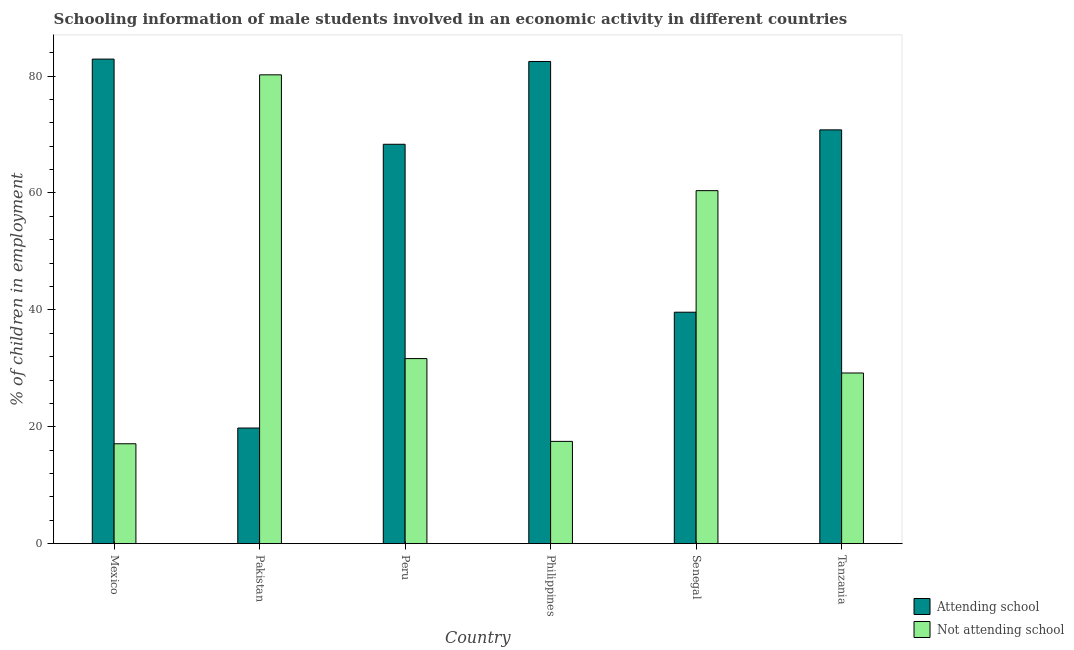How many different coloured bars are there?
Keep it short and to the point. 2. Are the number of bars per tick equal to the number of legend labels?
Make the answer very short. Yes. How many bars are there on the 5th tick from the right?
Your response must be concise. 2. In how many cases, is the number of bars for a given country not equal to the number of legend labels?
Provide a succinct answer. 0. What is the percentage of employed males who are not attending school in Senegal?
Provide a short and direct response. 60.4. Across all countries, what is the maximum percentage of employed males who are attending school?
Offer a terse response. 82.91. Across all countries, what is the minimum percentage of employed males who are attending school?
Your answer should be very brief. 19.79. What is the total percentage of employed males who are not attending school in the graph?
Provide a short and direct response. 236.07. What is the difference between the percentage of employed males who are attending school in Mexico and that in Tanzania?
Provide a succinct answer. 12.11. What is the difference between the percentage of employed males who are not attending school in Mexico and the percentage of employed males who are attending school in Pakistan?
Offer a terse response. -2.69. What is the average percentage of employed males who are attending school per country?
Make the answer very short. 60.65. What is the difference between the percentage of employed males who are not attending school and percentage of employed males who are attending school in Tanzania?
Offer a terse response. -41.6. In how many countries, is the percentage of employed males who are attending school greater than 52 %?
Provide a succinct answer. 4. What is the ratio of the percentage of employed males who are not attending school in Peru to that in Tanzania?
Give a very brief answer. 1.08. What is the difference between the highest and the second highest percentage of employed males who are attending school?
Your answer should be compact. 0.41. What is the difference between the highest and the lowest percentage of employed males who are not attending school?
Give a very brief answer. 63.12. In how many countries, is the percentage of employed males who are not attending school greater than the average percentage of employed males who are not attending school taken over all countries?
Offer a terse response. 2. What does the 2nd bar from the left in Pakistan represents?
Offer a very short reply. Not attending school. What does the 1st bar from the right in Philippines represents?
Provide a succinct answer. Not attending school. How many bars are there?
Ensure brevity in your answer.  12. Are the values on the major ticks of Y-axis written in scientific E-notation?
Provide a short and direct response. No. Does the graph contain any zero values?
Your response must be concise. No. What is the title of the graph?
Keep it short and to the point. Schooling information of male students involved in an economic activity in different countries. Does "Technicians" appear as one of the legend labels in the graph?
Your answer should be compact. No. What is the label or title of the X-axis?
Keep it short and to the point. Country. What is the label or title of the Y-axis?
Your answer should be compact. % of children in employment. What is the % of children in employment in Attending school in Mexico?
Your answer should be compact. 82.91. What is the % of children in employment of Not attending school in Mexico?
Your answer should be very brief. 17.09. What is the % of children in employment of Attending school in Pakistan?
Offer a very short reply. 19.79. What is the % of children in employment in Not attending school in Pakistan?
Provide a short and direct response. 80.21. What is the % of children in employment in Attending school in Peru?
Offer a very short reply. 68.33. What is the % of children in employment in Not attending school in Peru?
Offer a very short reply. 31.67. What is the % of children in employment in Attending school in Philippines?
Give a very brief answer. 82.5. What is the % of children in employment of Not attending school in Philippines?
Provide a short and direct response. 17.5. What is the % of children in employment of Attending school in Senegal?
Offer a terse response. 39.6. What is the % of children in employment of Not attending school in Senegal?
Provide a short and direct response. 60.4. What is the % of children in employment of Attending school in Tanzania?
Ensure brevity in your answer.  70.8. What is the % of children in employment in Not attending school in Tanzania?
Provide a succinct answer. 29.2. Across all countries, what is the maximum % of children in employment of Attending school?
Ensure brevity in your answer.  82.91. Across all countries, what is the maximum % of children in employment in Not attending school?
Offer a terse response. 80.21. Across all countries, what is the minimum % of children in employment in Attending school?
Your answer should be compact. 19.79. Across all countries, what is the minimum % of children in employment in Not attending school?
Your response must be concise. 17.09. What is the total % of children in employment of Attending school in the graph?
Offer a very short reply. 363.93. What is the total % of children in employment of Not attending school in the graph?
Your answer should be compact. 236.07. What is the difference between the % of children in employment in Attending school in Mexico and that in Pakistan?
Your response must be concise. 63.12. What is the difference between the % of children in employment of Not attending school in Mexico and that in Pakistan?
Ensure brevity in your answer.  -63.12. What is the difference between the % of children in employment of Attending school in Mexico and that in Peru?
Your answer should be compact. 14.57. What is the difference between the % of children in employment in Not attending school in Mexico and that in Peru?
Ensure brevity in your answer.  -14.57. What is the difference between the % of children in employment in Attending school in Mexico and that in Philippines?
Keep it short and to the point. 0.41. What is the difference between the % of children in employment in Not attending school in Mexico and that in Philippines?
Offer a terse response. -0.41. What is the difference between the % of children in employment in Attending school in Mexico and that in Senegal?
Ensure brevity in your answer.  43.31. What is the difference between the % of children in employment in Not attending school in Mexico and that in Senegal?
Keep it short and to the point. -43.31. What is the difference between the % of children in employment in Attending school in Mexico and that in Tanzania?
Offer a very short reply. 12.11. What is the difference between the % of children in employment in Not attending school in Mexico and that in Tanzania?
Give a very brief answer. -12.11. What is the difference between the % of children in employment of Attending school in Pakistan and that in Peru?
Provide a succinct answer. -48.55. What is the difference between the % of children in employment in Not attending school in Pakistan and that in Peru?
Your response must be concise. 48.55. What is the difference between the % of children in employment of Attending school in Pakistan and that in Philippines?
Ensure brevity in your answer.  -62.71. What is the difference between the % of children in employment in Not attending school in Pakistan and that in Philippines?
Provide a short and direct response. 62.71. What is the difference between the % of children in employment of Attending school in Pakistan and that in Senegal?
Offer a terse response. -19.81. What is the difference between the % of children in employment of Not attending school in Pakistan and that in Senegal?
Give a very brief answer. 19.81. What is the difference between the % of children in employment in Attending school in Pakistan and that in Tanzania?
Your answer should be very brief. -51.01. What is the difference between the % of children in employment in Not attending school in Pakistan and that in Tanzania?
Provide a succinct answer. 51.01. What is the difference between the % of children in employment of Attending school in Peru and that in Philippines?
Your answer should be very brief. -14.17. What is the difference between the % of children in employment in Not attending school in Peru and that in Philippines?
Offer a terse response. 14.17. What is the difference between the % of children in employment in Attending school in Peru and that in Senegal?
Offer a very short reply. 28.73. What is the difference between the % of children in employment of Not attending school in Peru and that in Senegal?
Your response must be concise. -28.73. What is the difference between the % of children in employment of Attending school in Peru and that in Tanzania?
Provide a short and direct response. -2.47. What is the difference between the % of children in employment in Not attending school in Peru and that in Tanzania?
Give a very brief answer. 2.47. What is the difference between the % of children in employment in Attending school in Philippines and that in Senegal?
Provide a short and direct response. 42.9. What is the difference between the % of children in employment in Not attending school in Philippines and that in Senegal?
Provide a short and direct response. -42.9. What is the difference between the % of children in employment of Attending school in Philippines and that in Tanzania?
Ensure brevity in your answer.  11.7. What is the difference between the % of children in employment in Not attending school in Philippines and that in Tanzania?
Offer a very short reply. -11.7. What is the difference between the % of children in employment of Attending school in Senegal and that in Tanzania?
Make the answer very short. -31.2. What is the difference between the % of children in employment of Not attending school in Senegal and that in Tanzania?
Give a very brief answer. 31.2. What is the difference between the % of children in employment in Attending school in Mexico and the % of children in employment in Not attending school in Pakistan?
Offer a very short reply. 2.69. What is the difference between the % of children in employment in Attending school in Mexico and the % of children in employment in Not attending school in Peru?
Your response must be concise. 51.24. What is the difference between the % of children in employment in Attending school in Mexico and the % of children in employment in Not attending school in Philippines?
Provide a short and direct response. 65.41. What is the difference between the % of children in employment of Attending school in Mexico and the % of children in employment of Not attending school in Senegal?
Keep it short and to the point. 22.51. What is the difference between the % of children in employment in Attending school in Mexico and the % of children in employment in Not attending school in Tanzania?
Ensure brevity in your answer.  53.71. What is the difference between the % of children in employment in Attending school in Pakistan and the % of children in employment in Not attending school in Peru?
Make the answer very short. -11.88. What is the difference between the % of children in employment of Attending school in Pakistan and the % of children in employment of Not attending school in Philippines?
Your answer should be very brief. 2.29. What is the difference between the % of children in employment of Attending school in Pakistan and the % of children in employment of Not attending school in Senegal?
Your answer should be compact. -40.61. What is the difference between the % of children in employment of Attending school in Pakistan and the % of children in employment of Not attending school in Tanzania?
Your answer should be very brief. -9.41. What is the difference between the % of children in employment of Attending school in Peru and the % of children in employment of Not attending school in Philippines?
Make the answer very short. 50.83. What is the difference between the % of children in employment in Attending school in Peru and the % of children in employment in Not attending school in Senegal?
Ensure brevity in your answer.  7.93. What is the difference between the % of children in employment of Attending school in Peru and the % of children in employment of Not attending school in Tanzania?
Offer a very short reply. 39.13. What is the difference between the % of children in employment of Attending school in Philippines and the % of children in employment of Not attending school in Senegal?
Provide a succinct answer. 22.1. What is the difference between the % of children in employment in Attending school in Philippines and the % of children in employment in Not attending school in Tanzania?
Provide a short and direct response. 53.3. What is the difference between the % of children in employment in Attending school in Senegal and the % of children in employment in Not attending school in Tanzania?
Ensure brevity in your answer.  10.4. What is the average % of children in employment in Attending school per country?
Provide a short and direct response. 60.65. What is the average % of children in employment of Not attending school per country?
Ensure brevity in your answer.  39.35. What is the difference between the % of children in employment in Attending school and % of children in employment in Not attending school in Mexico?
Provide a short and direct response. 65.81. What is the difference between the % of children in employment of Attending school and % of children in employment of Not attending school in Pakistan?
Offer a very short reply. -60.43. What is the difference between the % of children in employment of Attending school and % of children in employment of Not attending school in Peru?
Your answer should be compact. 36.67. What is the difference between the % of children in employment in Attending school and % of children in employment in Not attending school in Senegal?
Your response must be concise. -20.8. What is the difference between the % of children in employment of Attending school and % of children in employment of Not attending school in Tanzania?
Your answer should be compact. 41.6. What is the ratio of the % of children in employment in Attending school in Mexico to that in Pakistan?
Ensure brevity in your answer.  4.19. What is the ratio of the % of children in employment in Not attending school in Mexico to that in Pakistan?
Ensure brevity in your answer.  0.21. What is the ratio of the % of children in employment of Attending school in Mexico to that in Peru?
Make the answer very short. 1.21. What is the ratio of the % of children in employment in Not attending school in Mexico to that in Peru?
Your answer should be very brief. 0.54. What is the ratio of the % of children in employment of Attending school in Mexico to that in Philippines?
Offer a terse response. 1. What is the ratio of the % of children in employment in Not attending school in Mexico to that in Philippines?
Your answer should be compact. 0.98. What is the ratio of the % of children in employment of Attending school in Mexico to that in Senegal?
Make the answer very short. 2.09. What is the ratio of the % of children in employment in Not attending school in Mexico to that in Senegal?
Keep it short and to the point. 0.28. What is the ratio of the % of children in employment of Attending school in Mexico to that in Tanzania?
Provide a succinct answer. 1.17. What is the ratio of the % of children in employment of Not attending school in Mexico to that in Tanzania?
Keep it short and to the point. 0.59. What is the ratio of the % of children in employment of Attending school in Pakistan to that in Peru?
Provide a succinct answer. 0.29. What is the ratio of the % of children in employment of Not attending school in Pakistan to that in Peru?
Ensure brevity in your answer.  2.53. What is the ratio of the % of children in employment of Attending school in Pakistan to that in Philippines?
Provide a short and direct response. 0.24. What is the ratio of the % of children in employment of Not attending school in Pakistan to that in Philippines?
Offer a terse response. 4.58. What is the ratio of the % of children in employment in Attending school in Pakistan to that in Senegal?
Give a very brief answer. 0.5. What is the ratio of the % of children in employment of Not attending school in Pakistan to that in Senegal?
Offer a very short reply. 1.33. What is the ratio of the % of children in employment of Attending school in Pakistan to that in Tanzania?
Your response must be concise. 0.28. What is the ratio of the % of children in employment in Not attending school in Pakistan to that in Tanzania?
Give a very brief answer. 2.75. What is the ratio of the % of children in employment of Attending school in Peru to that in Philippines?
Your answer should be very brief. 0.83. What is the ratio of the % of children in employment of Not attending school in Peru to that in Philippines?
Your answer should be very brief. 1.81. What is the ratio of the % of children in employment of Attending school in Peru to that in Senegal?
Provide a short and direct response. 1.73. What is the ratio of the % of children in employment of Not attending school in Peru to that in Senegal?
Give a very brief answer. 0.52. What is the ratio of the % of children in employment in Attending school in Peru to that in Tanzania?
Make the answer very short. 0.97. What is the ratio of the % of children in employment of Not attending school in Peru to that in Tanzania?
Your answer should be compact. 1.08. What is the ratio of the % of children in employment in Attending school in Philippines to that in Senegal?
Ensure brevity in your answer.  2.08. What is the ratio of the % of children in employment of Not attending school in Philippines to that in Senegal?
Give a very brief answer. 0.29. What is the ratio of the % of children in employment of Attending school in Philippines to that in Tanzania?
Your answer should be compact. 1.17. What is the ratio of the % of children in employment in Not attending school in Philippines to that in Tanzania?
Offer a terse response. 0.6. What is the ratio of the % of children in employment in Attending school in Senegal to that in Tanzania?
Provide a short and direct response. 0.56. What is the ratio of the % of children in employment in Not attending school in Senegal to that in Tanzania?
Provide a succinct answer. 2.07. What is the difference between the highest and the second highest % of children in employment in Attending school?
Your answer should be compact. 0.41. What is the difference between the highest and the second highest % of children in employment of Not attending school?
Your response must be concise. 19.81. What is the difference between the highest and the lowest % of children in employment in Attending school?
Ensure brevity in your answer.  63.12. What is the difference between the highest and the lowest % of children in employment of Not attending school?
Offer a terse response. 63.12. 